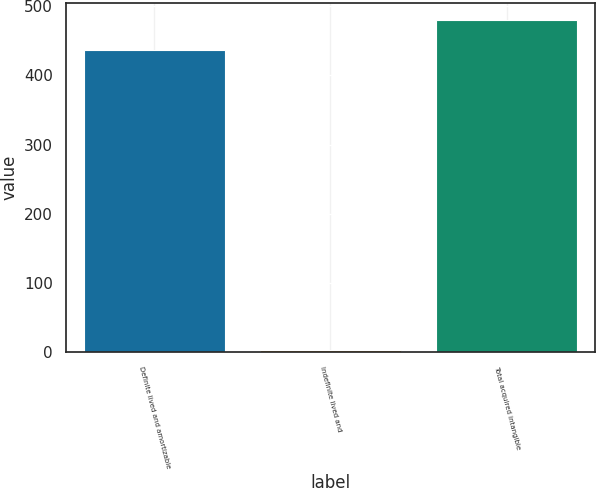<chart> <loc_0><loc_0><loc_500><loc_500><bar_chart><fcel>Definite lived and amortizable<fcel>Indefinite lived and<fcel>Total acquired intangible<nl><fcel>437<fcel>2.5<fcel>480.45<nl></chart> 